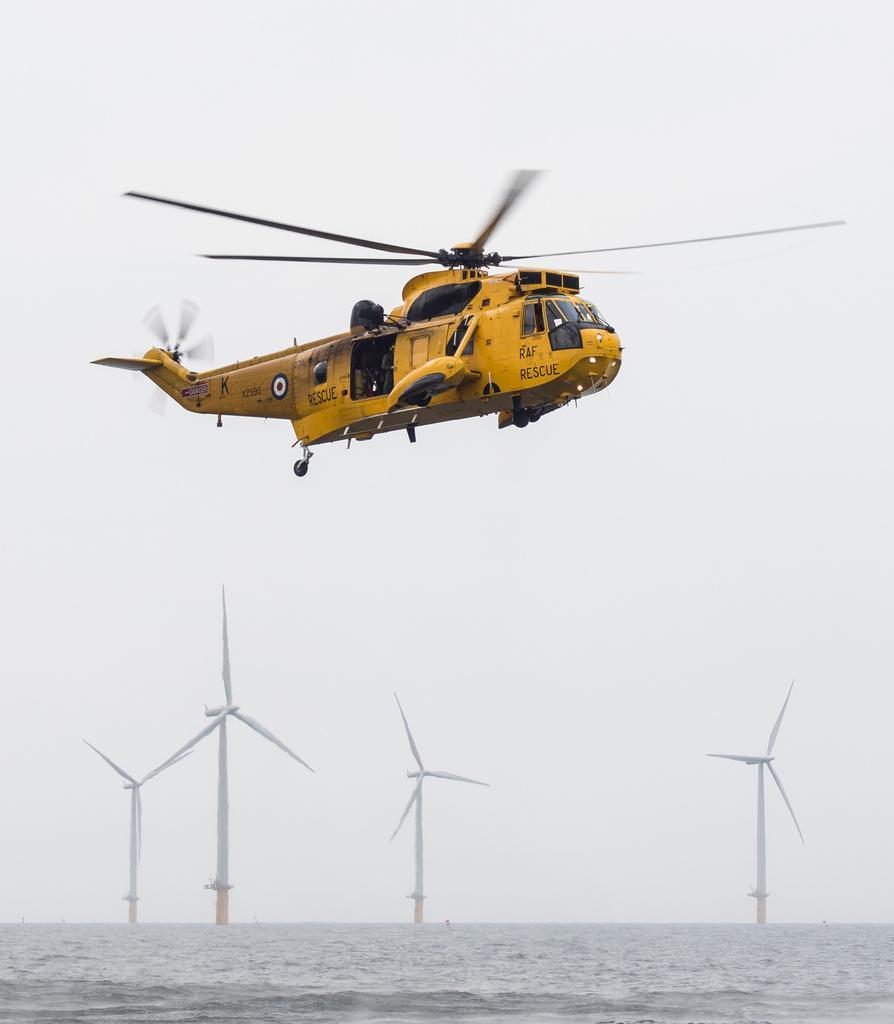Describe this image in one or two sentences. In the center of the image we can see a helicopter flying in the sky. At the bottom there is water and we can see windmills. 